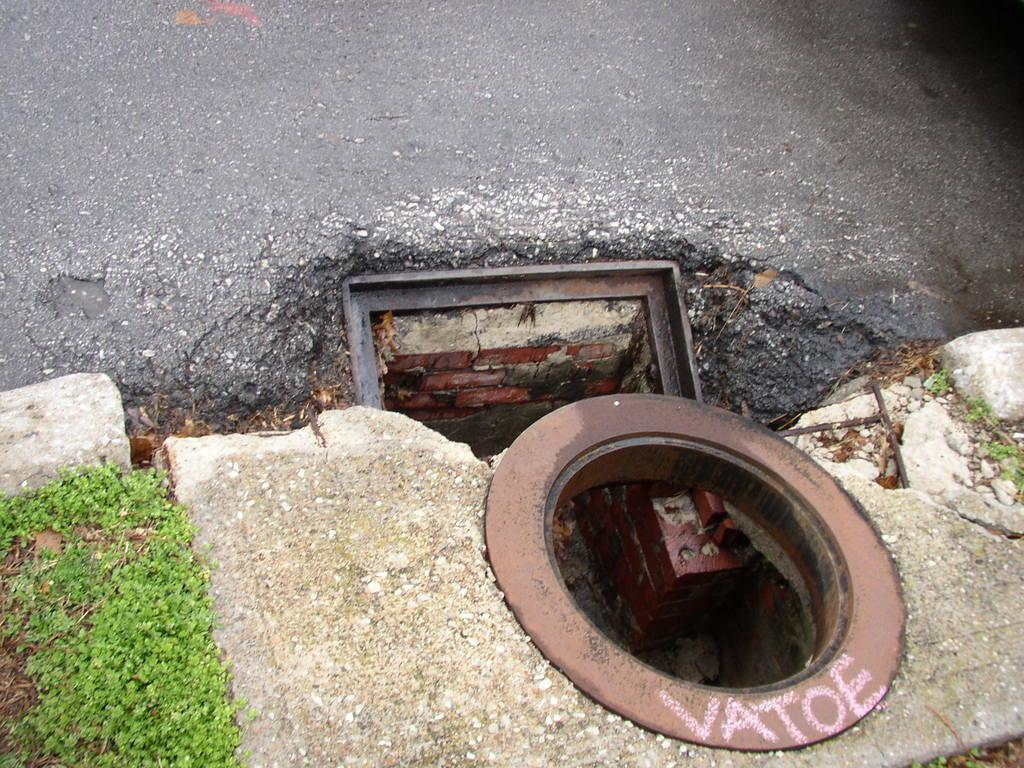What can be seen in the image that has holes? There are metallic objects in the image that have holes. Can you describe the metallic objects in the image? The metallic objects in the image have holes and are likely used for a specific purpose. What is the unusual feature of the road in the image? There is grass on the road in the image. How does the grass on the road react during a rainstorm? There is no rainstorm present in the image, so it is not possible to determine how the grass on the road would react during a rainstorm. 